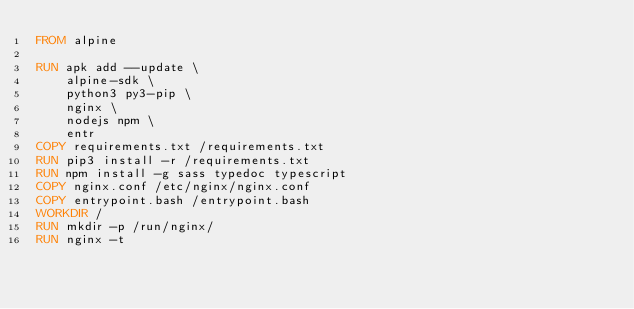Convert code to text. <code><loc_0><loc_0><loc_500><loc_500><_Dockerfile_>FROM alpine

RUN apk add --update \
    alpine-sdk \
    python3 py3-pip \
    nginx \
    nodejs npm \
    entr
COPY requirements.txt /requirements.txt
RUN pip3 install -r /requirements.txt
RUN npm install -g sass typedoc typescript
COPY nginx.conf /etc/nginx/nginx.conf
COPY entrypoint.bash /entrypoint.bash
WORKDIR /
RUN mkdir -p /run/nginx/
RUN nginx -t
</code> 